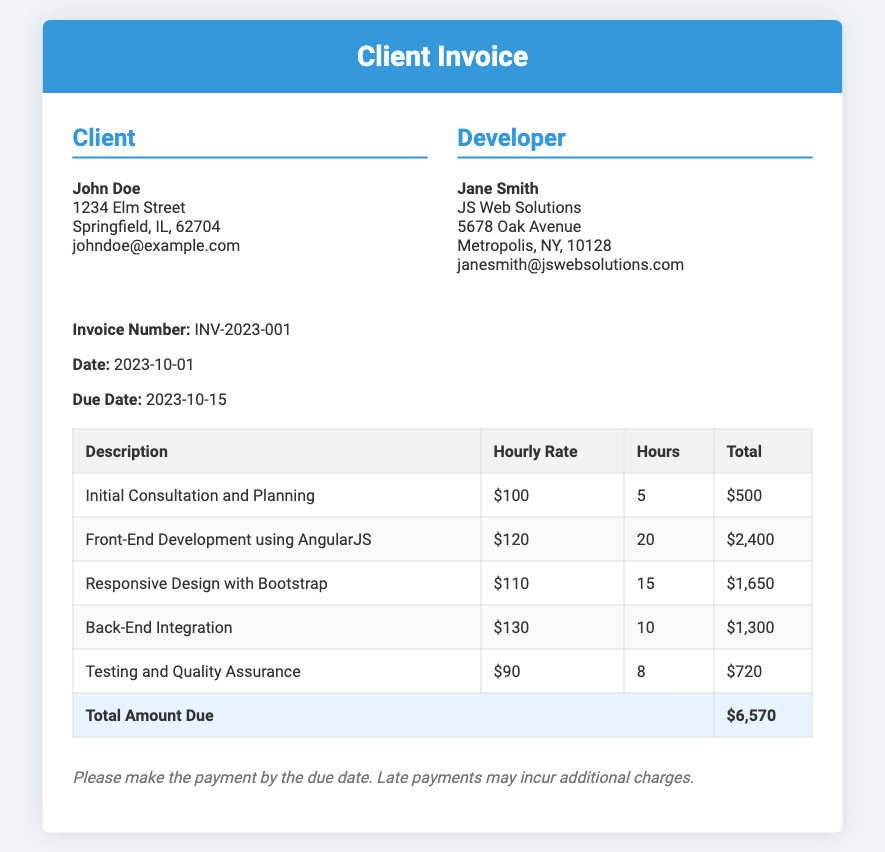what is the client's name? The client's name is listed at the top of the document under the client information section.
Answer: John Doe what is the invoice number? The invoice number is displayed in the invoice meta section, which identifies this specific invoice.
Answer: INV-2023-001 what is the hourly rate for Front-End Development? The hourly rate for Front-End Development can be found in the invoice table corresponding to that service description.
Answer: $120 how many hours were billed for Testing and Quality Assurance? The number of hours billed for Testing and Quality Assurance is available in the invoice table under the relevant service description.
Answer: 8 what is the total amount due? The total amount due is calculated as the aggregate of all service totals in the invoice table, highlighted at the bottom.
Answer: $6,570 who is the developer? The developer's name is listed in the developer information section of the document.
Answer: Jane Smith when is the payment due? The due date for payment is specified in the invoice meta section.
Answer: 2023-10-15 which service has the highest hourly rate? The service with the highest hourly rate can be identified by comparing the hourly rates in the invoice table.
Answer: Back-End Integration what is the payment term mentioned? The payment terms specify the conditions surrounding payment deadlines and additional charges outlined in the document.
Answer: Please make the payment by the due date 